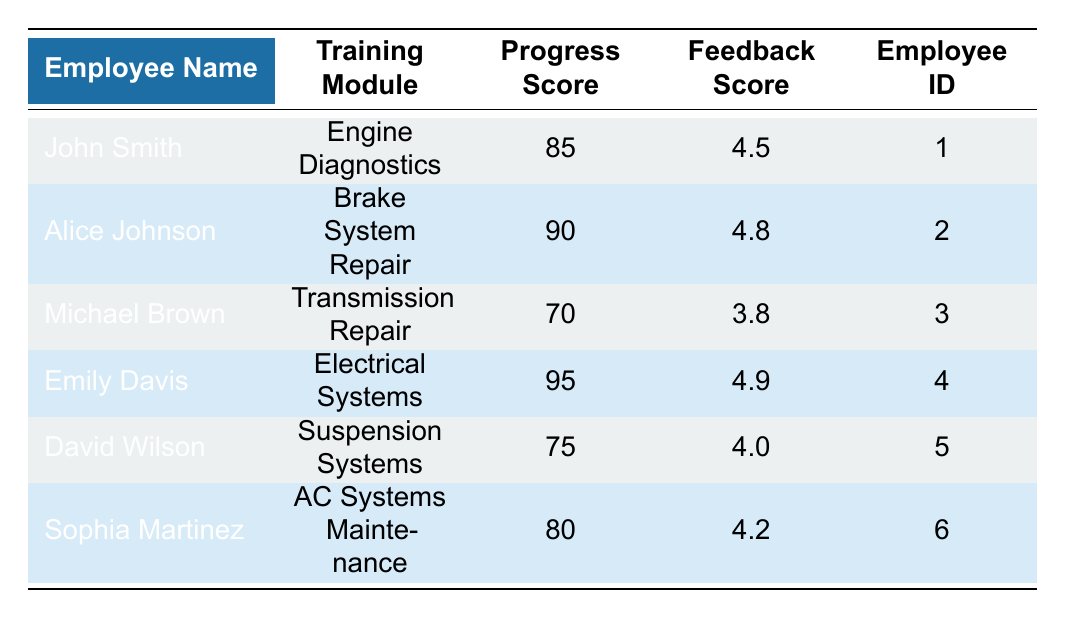What is the Progress Score of Emily Davis? Emily Davis is listed in the table under the "Employee Name" column. By looking across her row, I can see her "Progress Score" is noted as 95.
Answer: 95 Which employee received the highest Feedback Score? To determine this, I will look at the "Feedback Score" column and identify the maximum value. Emily Davis has the highest score at 4.9, making her the employee with the highest Feedback Score.
Answer: Emily Davis What is the average Progress Score of all employees? I will sum all the Progress Scores: 85 (John Smith) + 90 (Alice Johnson) + 70 (Michael Brown) + 95 (Emily Davis) + 75 (David Wilson) + 80 (Sophia Martinez) = 495. There are 6 employees, so I will divide the total by 6: 495 / 6 = 82.5.
Answer: 82.5 Is the Progress Score of Michael Brown above 75? Michael Brown's Progress Score is 70, which is less than 75. Therefore, the statement is false.
Answer: No How many employees have a Feedback Score above 4.5? I will count the employees with Feedback Scores greater than 4.5: Alice Johnson (4.8), Emily Davis (4.9), and Sophia Martinez (4.2) for a total of 2 employees.
Answer: 2 What is the difference between the highest and lowest Progress Scores? The highest Progress Score is 95 (Emily Davis), and the lowest is 70 (Michael Brown). The difference is calculated as 95 - 70 = 25.
Answer: 25 Which training module has the lowest Progress Score? The lowest Progress Score in the table is 70 for the training module "Transmission Repair," associated with Michael Brown.
Answer: Transmission Repair Is Alice Johnson's Progress Score equal to David Wilson's? I will compare Alice Johnson's Progress Score (90) with David Wilson's (75). Since they are not equal, the answer is no.
Answer: No 